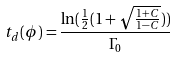<formula> <loc_0><loc_0><loc_500><loc_500>t _ { d } ( \phi ) = \frac { \ln ( \frac { 1 } { 2 } ( 1 + \sqrt { \frac { 1 + C } { 1 - C } } ) ) } { \Gamma _ { 0 } }</formula> 